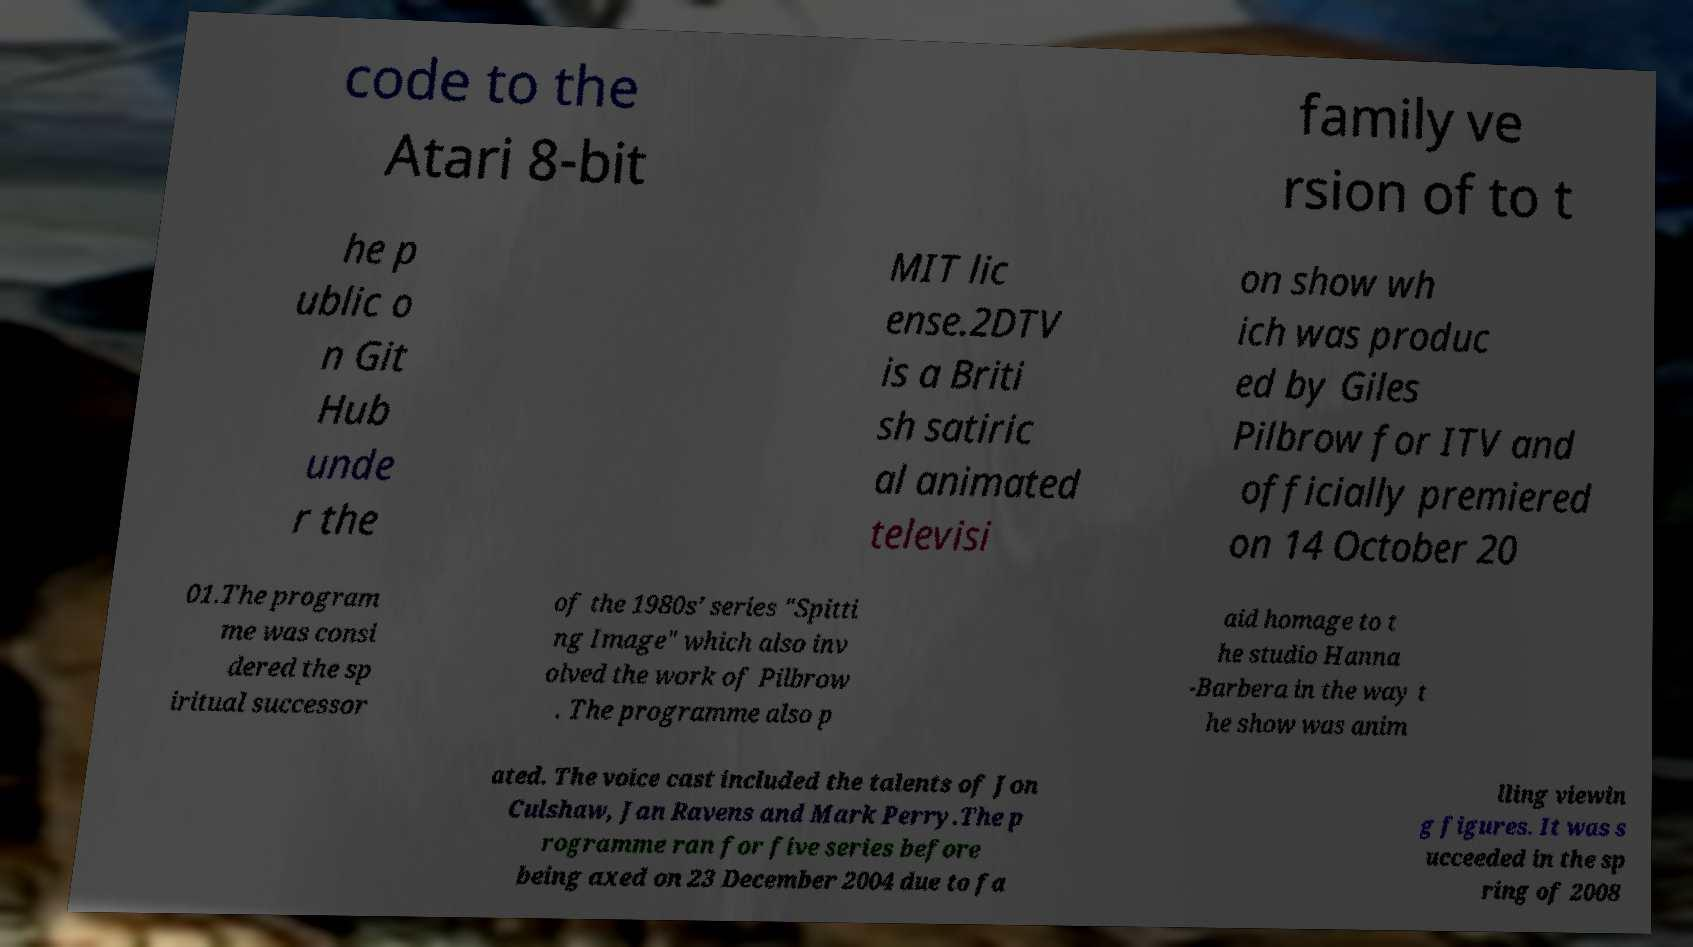Please read and relay the text visible in this image. What does it say? code to the Atari 8-bit family ve rsion of to t he p ublic o n Git Hub unde r the MIT lic ense.2DTV is a Briti sh satiric al animated televisi on show wh ich was produc ed by Giles Pilbrow for ITV and officially premiered on 14 October 20 01.The program me was consi dered the sp iritual successor of the 1980s’ series "Spitti ng Image" which also inv olved the work of Pilbrow . The programme also p aid homage to t he studio Hanna -Barbera in the way t he show was anim ated. The voice cast included the talents of Jon Culshaw, Jan Ravens and Mark Perry.The p rogramme ran for five series before being axed on 23 December 2004 due to fa lling viewin g figures. It was s ucceeded in the sp ring of 2008 